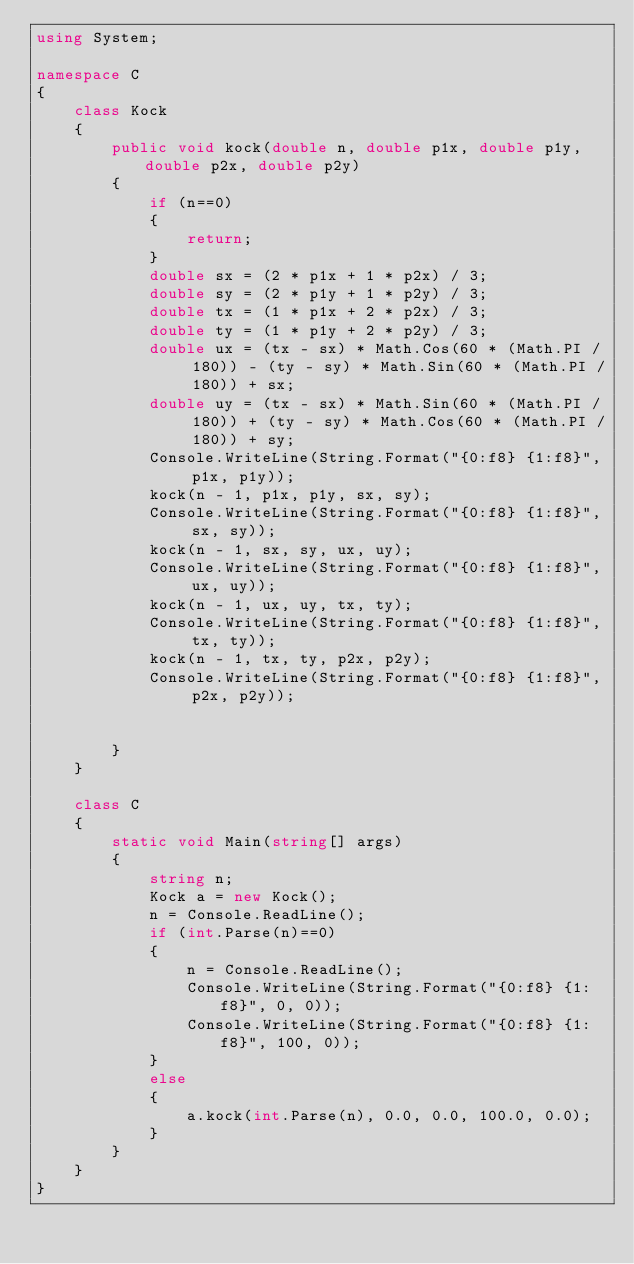Convert code to text. <code><loc_0><loc_0><loc_500><loc_500><_C#_>using System;

namespace C
{
    class Kock
    {
        public void kock(double n, double p1x, double p1y, double p2x, double p2y)
        {
            if (n==0)
            {
                return;
            }
            double sx = (2 * p1x + 1 * p2x) / 3;
            double sy = (2 * p1y + 1 * p2y) / 3;
            double tx = (1 * p1x + 2 * p2x) / 3;
            double ty = (1 * p1y + 2 * p2y) / 3;
            double ux = (tx - sx) * Math.Cos(60 * (Math.PI / 180)) - (ty - sy) * Math.Sin(60 * (Math.PI / 180)) + sx;
            double uy = (tx - sx) * Math.Sin(60 * (Math.PI / 180)) + (ty - sy) * Math.Cos(60 * (Math.PI / 180)) + sy;
            Console.WriteLine(String.Format("{0:f8} {1:f8}", p1x, p1y));
            kock(n - 1, p1x, p1y, sx, sy);
            Console.WriteLine(String.Format("{0:f8} {1:f8}", sx, sy));
            kock(n - 1, sx, sy, ux, uy);
            Console.WriteLine(String.Format("{0:f8} {1:f8}", ux, uy));
            kock(n - 1, ux, uy, tx, ty);
            Console.WriteLine(String.Format("{0:f8} {1:f8}", tx, ty));
            kock(n - 1, tx, ty, p2x, p2y);
            Console.WriteLine(String.Format("{0:f8} {1:f8}", p2x, p2y));
            

        }
    }

    class C
    {
        static void Main(string[] args)
        {
            string n;
            Kock a = new Kock();
            n = Console.ReadLine();
            if (int.Parse(n)==0)
            {
                n = Console.ReadLine();
                Console.WriteLine(String.Format("{0:f8} {1:f8}", 0, 0));
                Console.WriteLine(String.Format("{0:f8} {1:f8}", 100, 0));
            }
            else
            {
                a.kock(int.Parse(n), 0.0, 0.0, 100.0, 0.0);
            }
        }
    }
}

</code> 